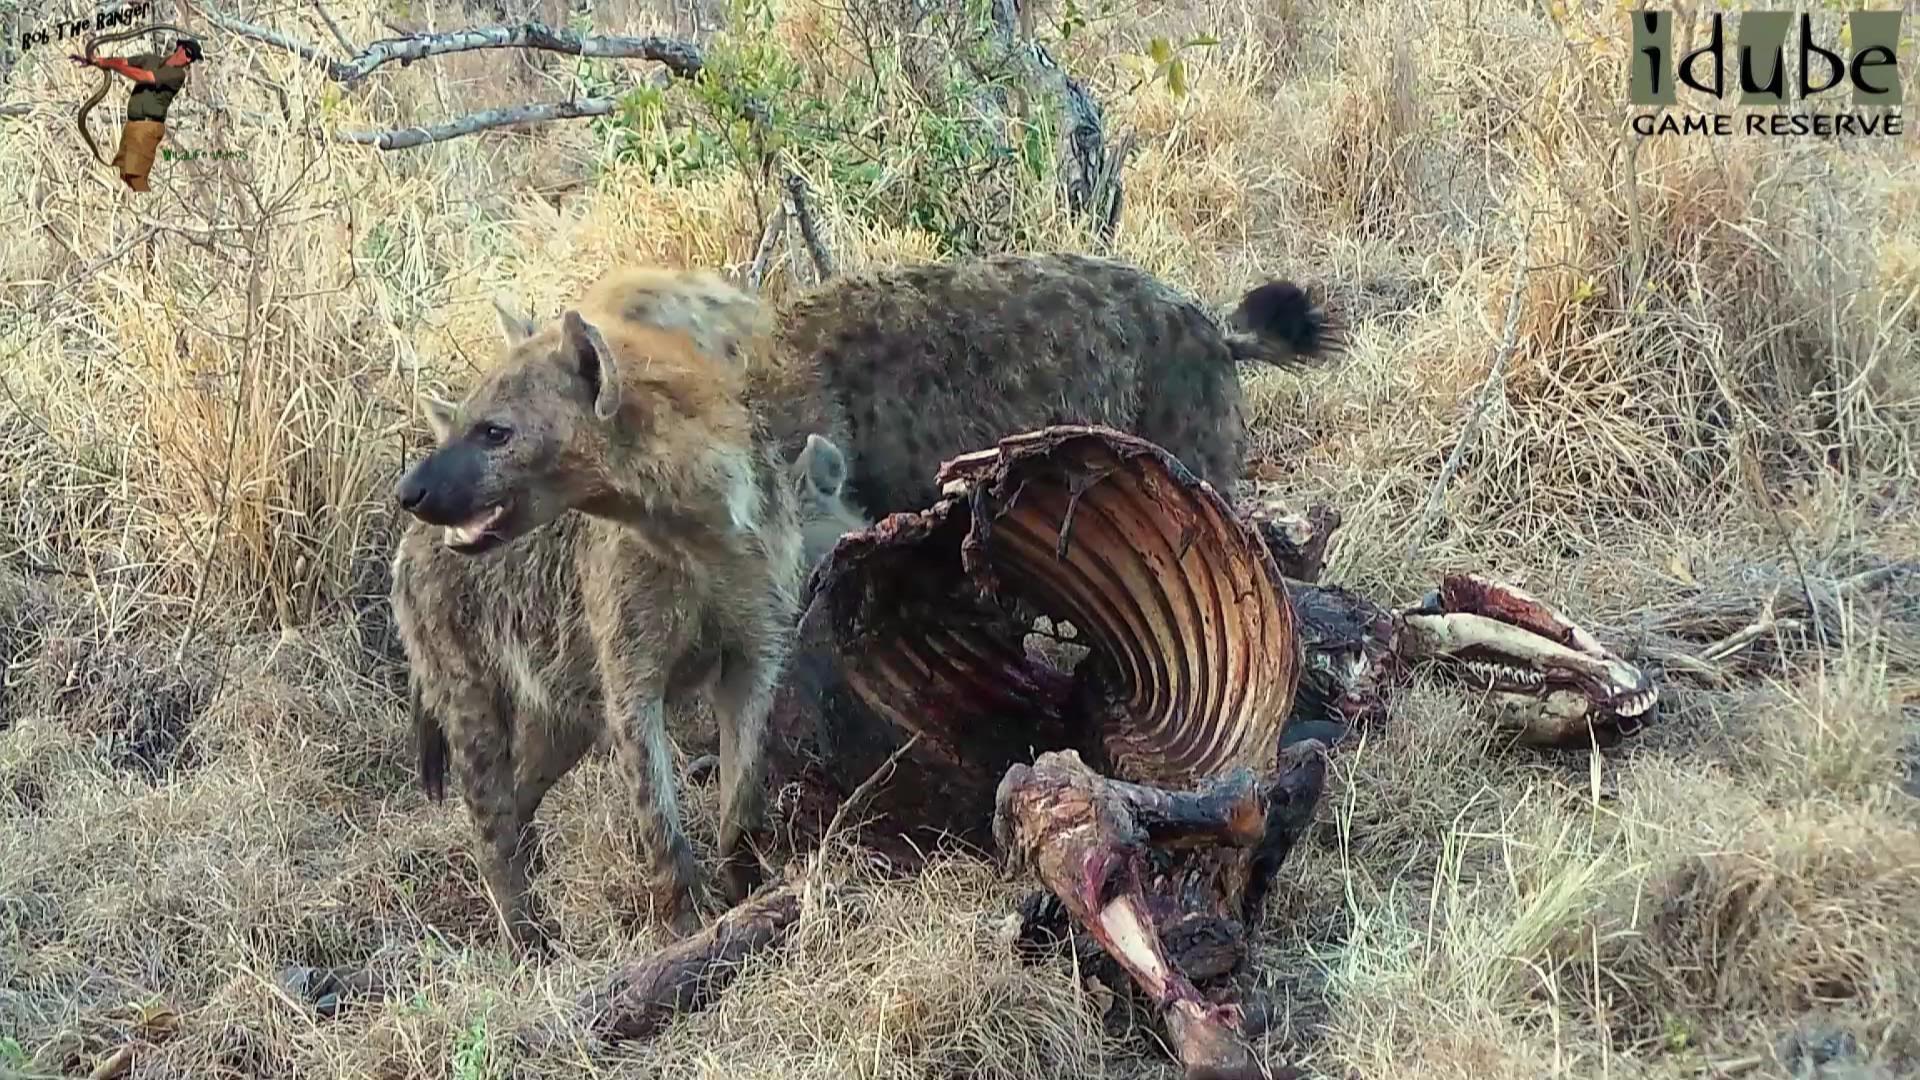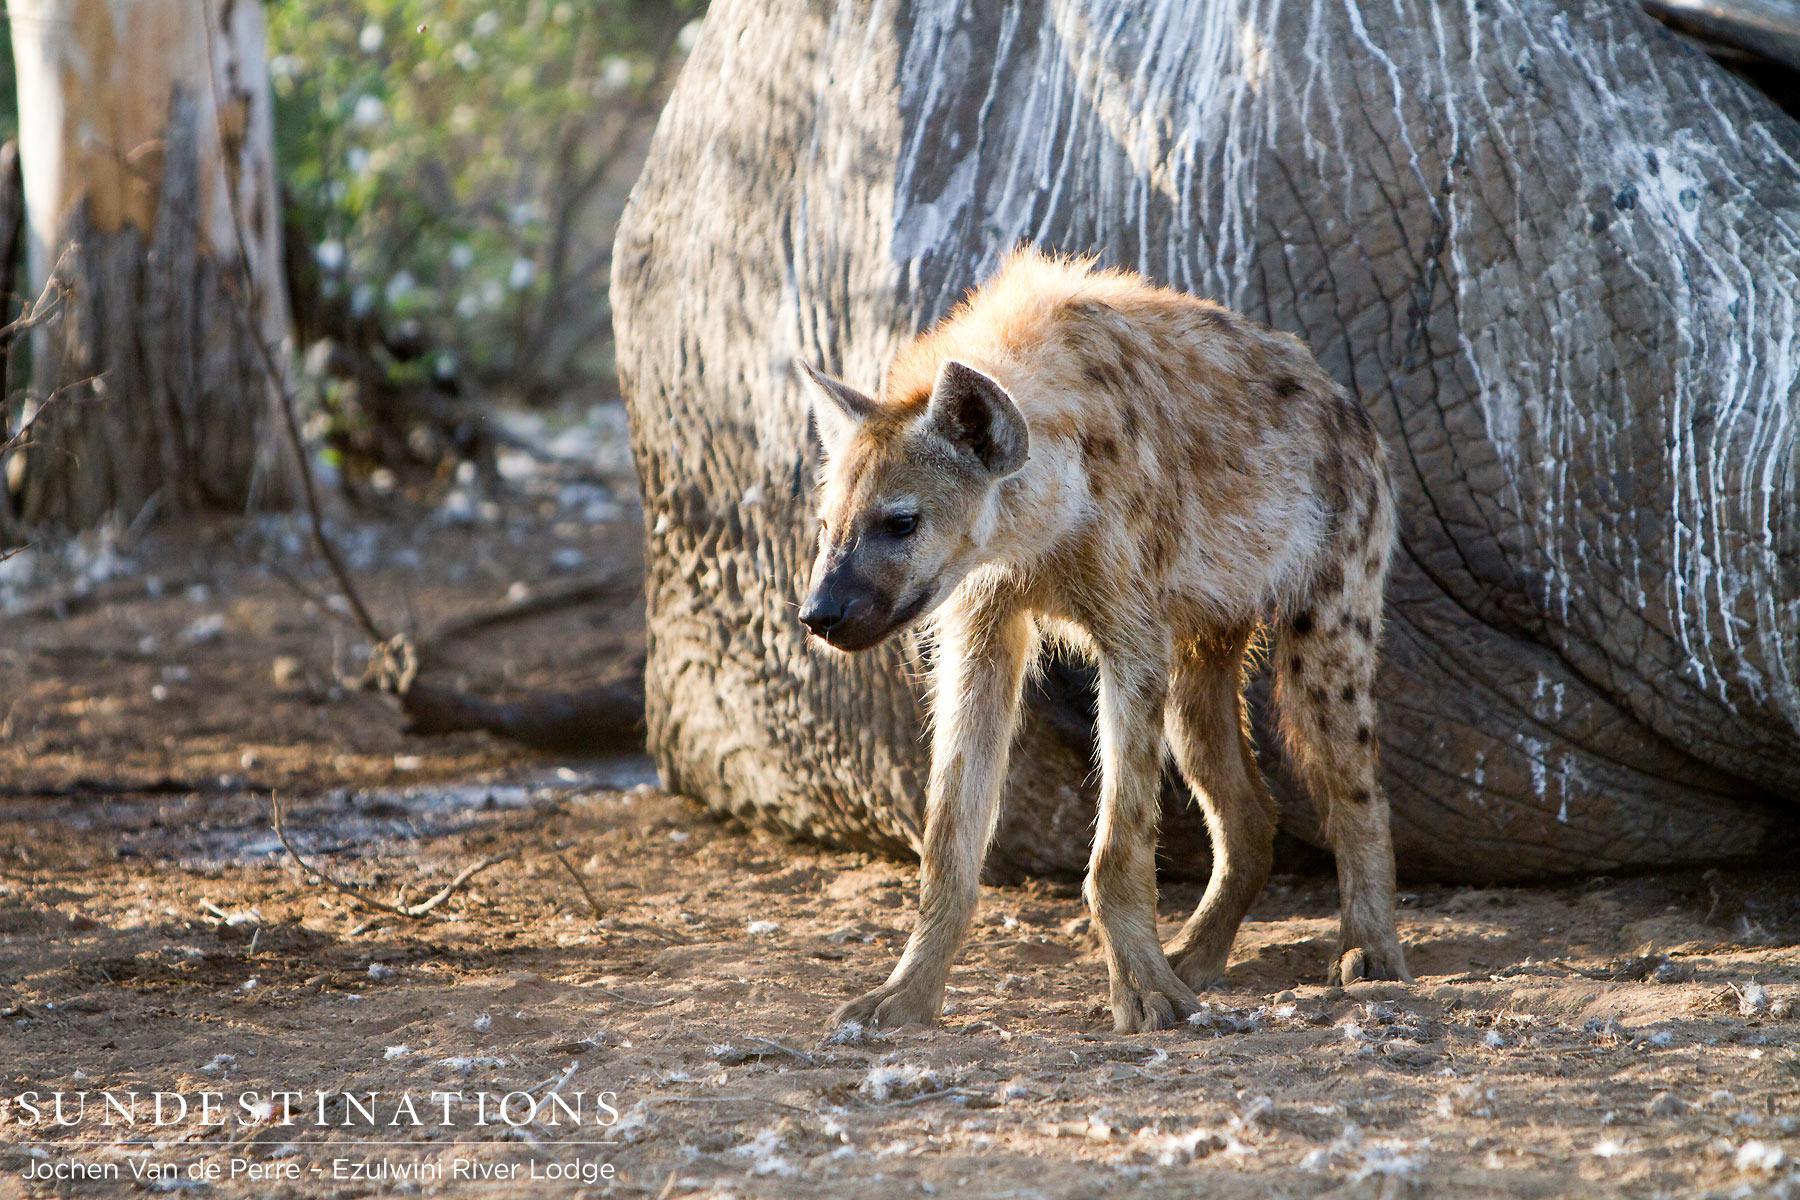The first image is the image on the left, the second image is the image on the right. Assess this claim about the two images: "In at least one image there is a single hyena with its mouth facing the dead prey.". Correct or not? Answer yes or no. No. The first image is the image on the left, the second image is the image on the right. For the images shown, is this caption "The right image includes at least one leftward-facing hyena standing in front of a large rock, but does not include a carcass or any other type of animal in the foreground." true? Answer yes or no. Yes. 